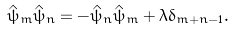Convert formula to latex. <formula><loc_0><loc_0><loc_500><loc_500>\hat { \psi } _ { m } \hat { \psi } _ { n } = - \hat { \psi } _ { n } \hat { \psi } _ { m } + \lambda \delta _ { m + n - 1 } .</formula> 